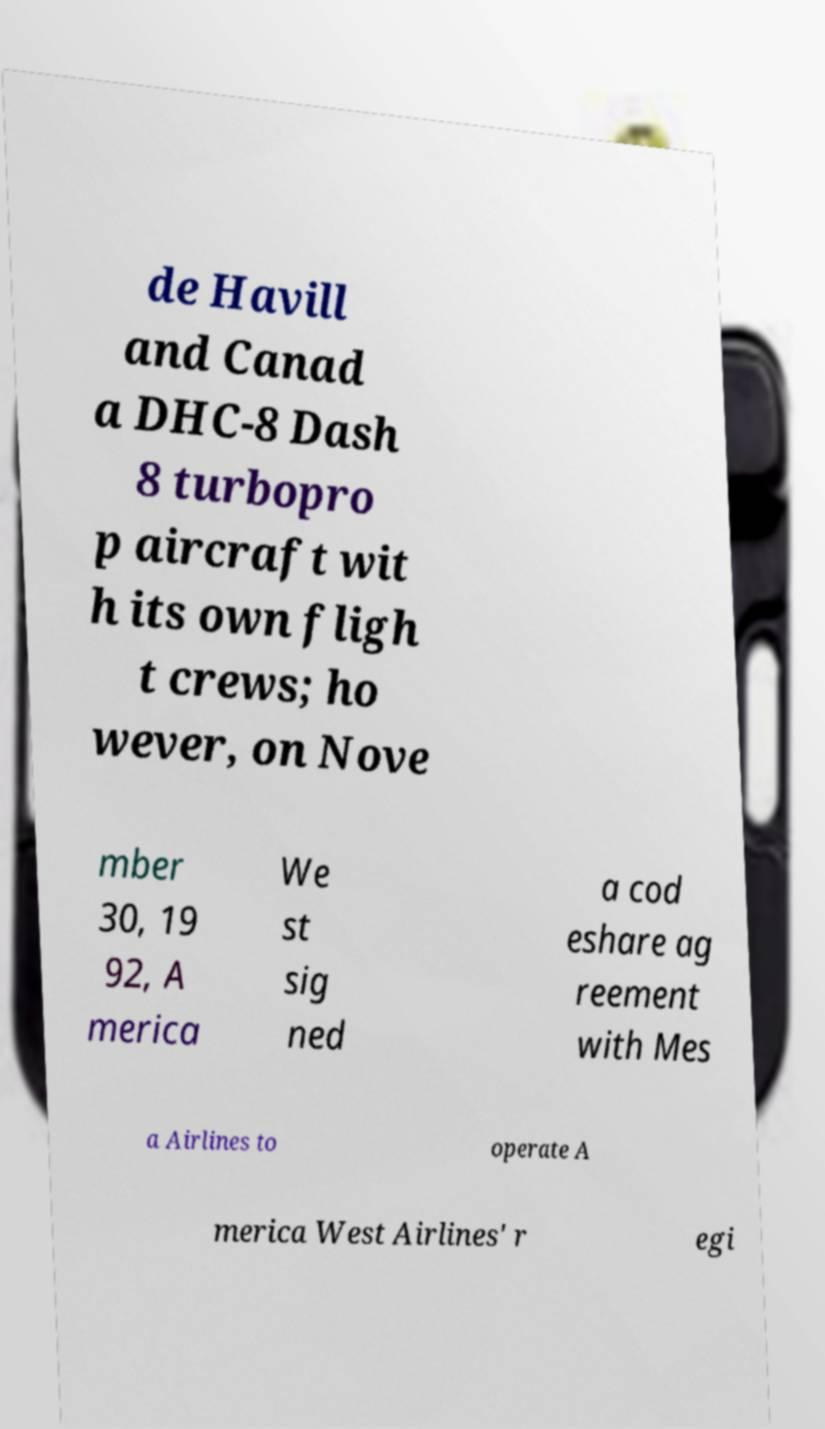Can you accurately transcribe the text from the provided image for me? de Havill and Canad a DHC-8 Dash 8 turbopro p aircraft wit h its own fligh t crews; ho wever, on Nove mber 30, 19 92, A merica We st sig ned a cod eshare ag reement with Mes a Airlines to operate A merica West Airlines' r egi 